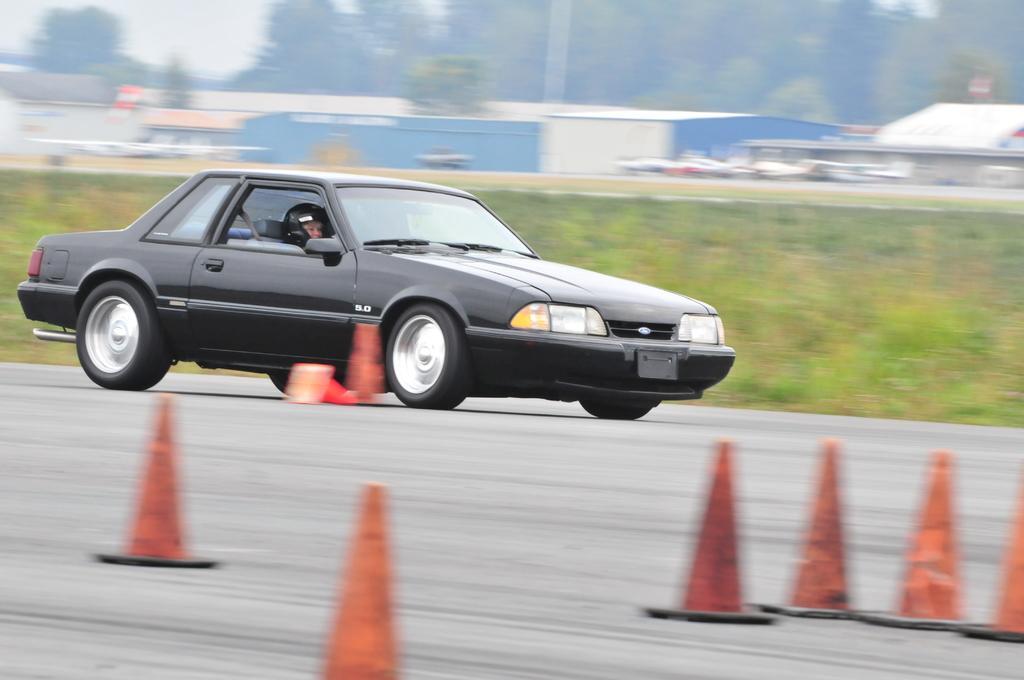Describe this image in one or two sentences. In this image I can see the road. On the road I can see the vehicle and the person in it. To the side of the vehicle there are many traffic cones. In the background I can see the sheds, many trees and the sky. 